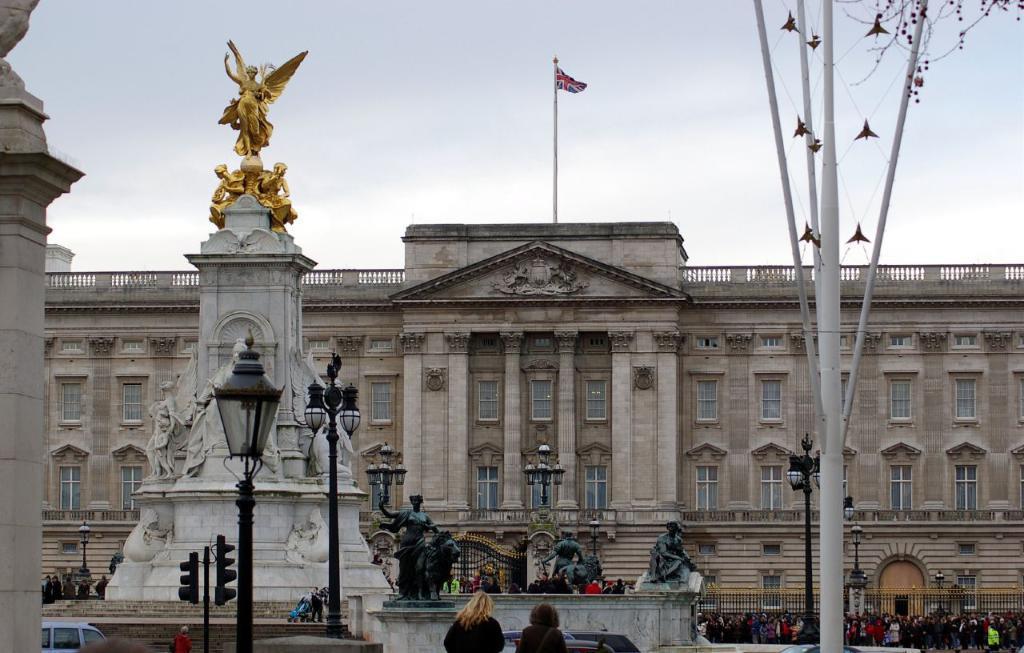Please provide a concise description of this image. In the image in the center, we can see the poles, statues, vehicles, traffic lights and group of people are standing. In the background, we can see the sky, clouds, buildings, windows, pillars, fence, wall, flag, gate etc. 